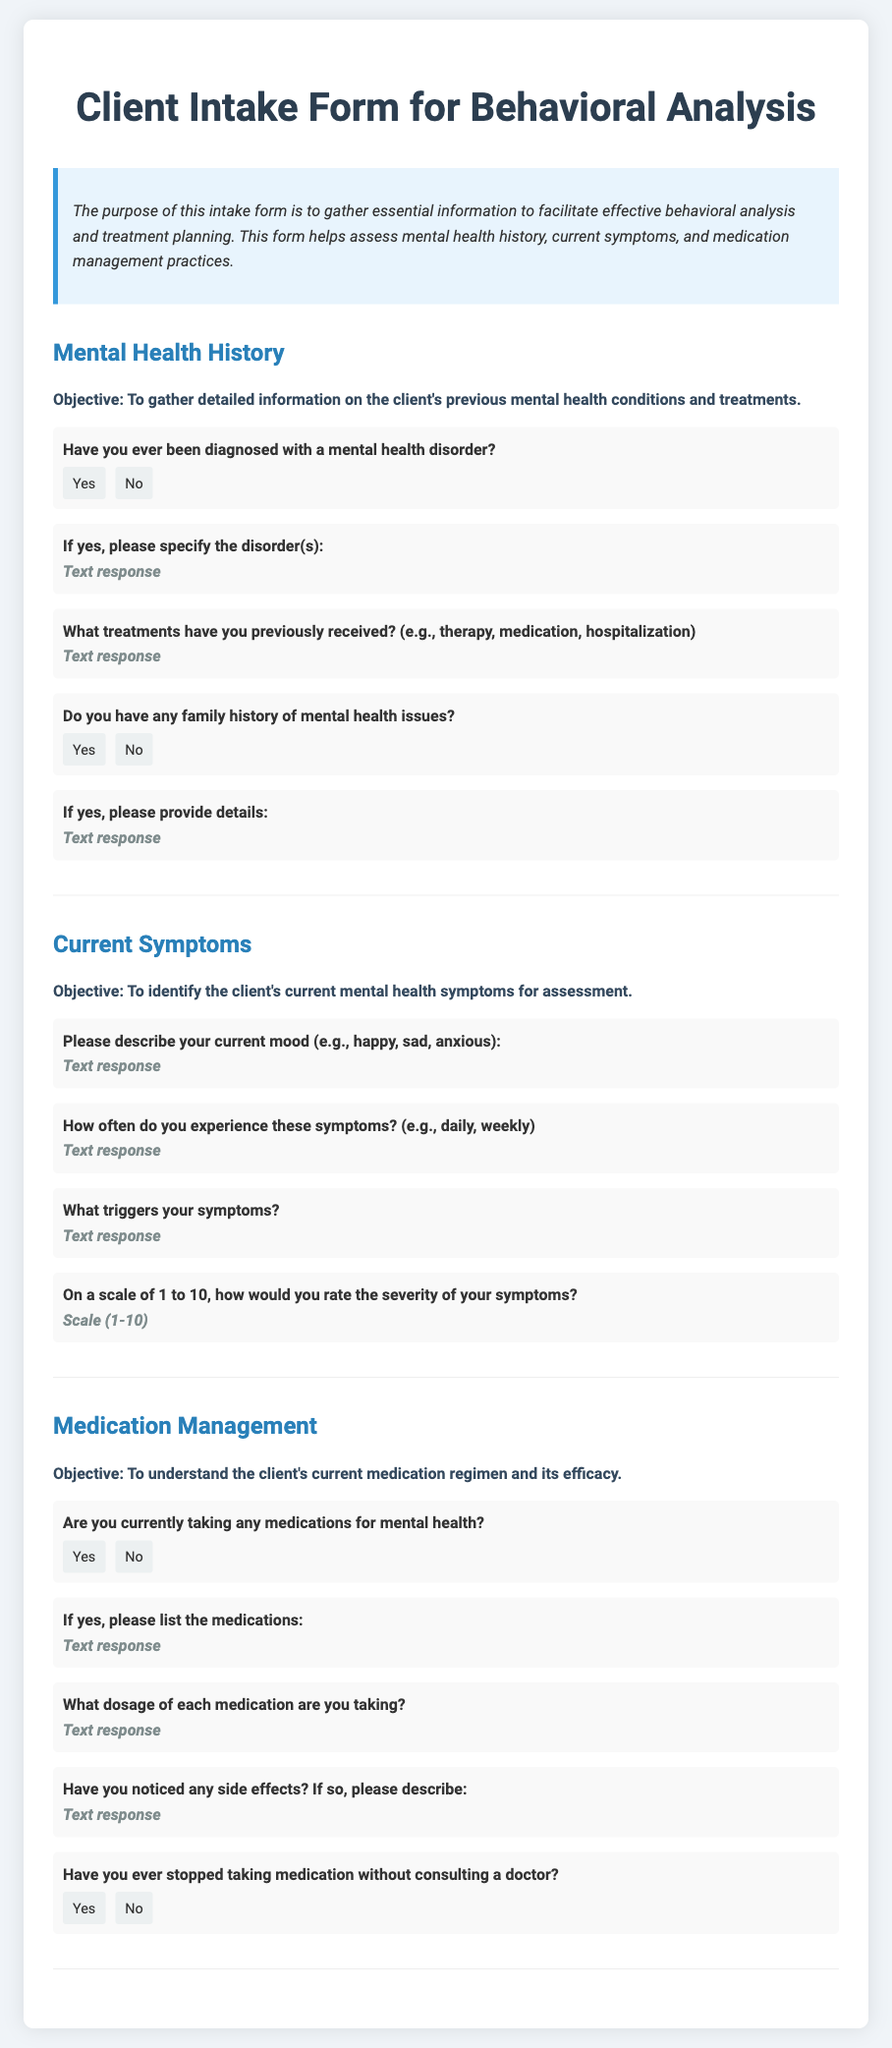What is the objective of the Mental Health History section? The objective is to gather detailed information on the client's previous mental health conditions and treatments.
Answer: To gather detailed information on the client's previous mental health conditions and treatments What question asks about family mental health history? The question "Do you have any family history of mental health issues?" seeks information about the client's family mental health.
Answer: Do you have any family history of mental health issues? What scale is used to rate symptom severity? The document indicates a scale of 1 to 10 is used to rate the severity of symptoms.
Answer: Scale (1-10) What kind of responses are expected for the question about current mood? The response format for the current mood question expects a text response that describes feelings.
Answer: Text response How many questions are in the Medication Management section? The Medication Management section contains four questions.
Answer: Four questions 